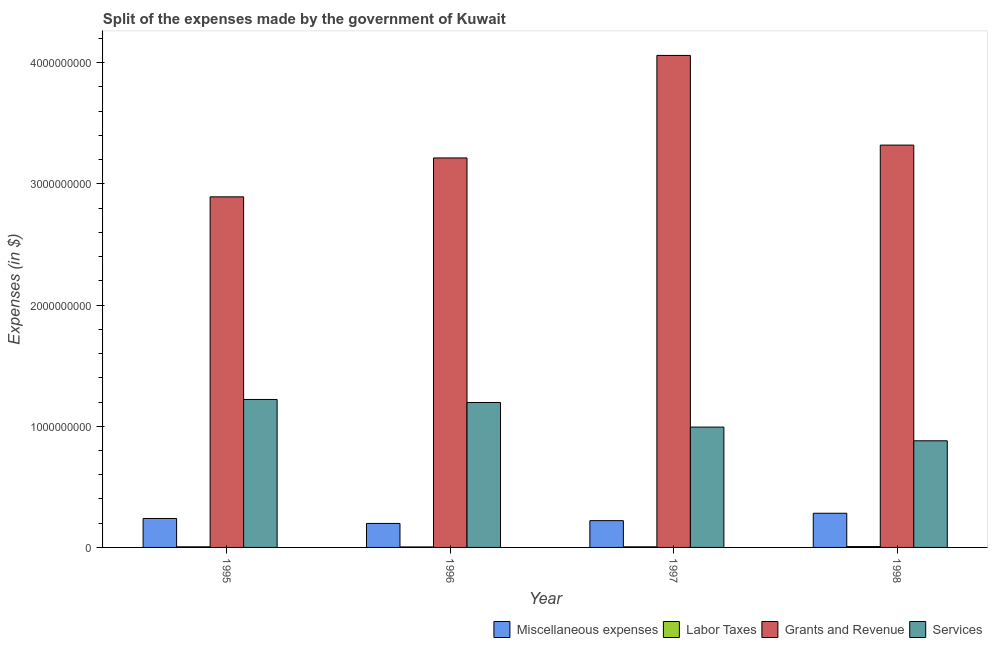How many groups of bars are there?
Offer a terse response. 4. Are the number of bars on each tick of the X-axis equal?
Keep it short and to the point. Yes. How many bars are there on the 1st tick from the left?
Your answer should be compact. 4. What is the amount spent on grants and revenue in 1995?
Make the answer very short. 2.89e+09. Across all years, what is the maximum amount spent on grants and revenue?
Offer a terse response. 4.06e+09. Across all years, what is the minimum amount spent on miscellaneous expenses?
Provide a succinct answer. 1.98e+08. In which year was the amount spent on labor taxes maximum?
Ensure brevity in your answer.  1998. In which year was the amount spent on miscellaneous expenses minimum?
Provide a succinct answer. 1996. What is the total amount spent on services in the graph?
Your answer should be very brief. 4.29e+09. What is the difference between the amount spent on grants and revenue in 1996 and that in 1998?
Provide a succinct answer. -1.06e+08. What is the difference between the amount spent on labor taxes in 1998 and the amount spent on services in 1996?
Offer a terse response. 3.00e+06. What is the average amount spent on services per year?
Keep it short and to the point. 1.07e+09. In the year 1995, what is the difference between the amount spent on services and amount spent on labor taxes?
Provide a short and direct response. 0. In how many years, is the amount spent on grants and revenue greater than 1800000000 $?
Offer a terse response. 4. What is the ratio of the amount spent on services in 1995 to that in 1998?
Provide a succinct answer. 1.39. What is the difference between the highest and the second highest amount spent on services?
Ensure brevity in your answer.  2.50e+07. What is the difference between the highest and the lowest amount spent on services?
Your answer should be very brief. 3.41e+08. In how many years, is the amount spent on miscellaneous expenses greater than the average amount spent on miscellaneous expenses taken over all years?
Ensure brevity in your answer.  2. What does the 3rd bar from the left in 1995 represents?
Provide a short and direct response. Grants and Revenue. What does the 1st bar from the right in 1998 represents?
Keep it short and to the point. Services. Is it the case that in every year, the sum of the amount spent on miscellaneous expenses and amount spent on labor taxes is greater than the amount spent on grants and revenue?
Give a very brief answer. No. Does the graph contain grids?
Keep it short and to the point. No. Where does the legend appear in the graph?
Offer a very short reply. Bottom right. How are the legend labels stacked?
Offer a terse response. Horizontal. What is the title of the graph?
Make the answer very short. Split of the expenses made by the government of Kuwait. What is the label or title of the X-axis?
Offer a very short reply. Year. What is the label or title of the Y-axis?
Your answer should be compact. Expenses (in $). What is the Expenses (in $) of Miscellaneous expenses in 1995?
Ensure brevity in your answer.  2.39e+08. What is the Expenses (in $) in Grants and Revenue in 1995?
Ensure brevity in your answer.  2.89e+09. What is the Expenses (in $) in Services in 1995?
Make the answer very short. 1.22e+09. What is the Expenses (in $) in Miscellaneous expenses in 1996?
Give a very brief answer. 1.98e+08. What is the Expenses (in $) of Grants and Revenue in 1996?
Your answer should be very brief. 3.21e+09. What is the Expenses (in $) of Services in 1996?
Ensure brevity in your answer.  1.20e+09. What is the Expenses (in $) of Miscellaneous expenses in 1997?
Provide a short and direct response. 2.21e+08. What is the Expenses (in $) in Grants and Revenue in 1997?
Keep it short and to the point. 4.06e+09. What is the Expenses (in $) in Services in 1997?
Your answer should be very brief. 9.93e+08. What is the Expenses (in $) in Miscellaneous expenses in 1998?
Ensure brevity in your answer.  2.82e+08. What is the Expenses (in $) in Labor Taxes in 1998?
Provide a succinct answer. 7.00e+06. What is the Expenses (in $) in Grants and Revenue in 1998?
Provide a succinct answer. 3.32e+09. What is the Expenses (in $) of Services in 1998?
Your response must be concise. 8.80e+08. Across all years, what is the maximum Expenses (in $) in Miscellaneous expenses?
Make the answer very short. 2.82e+08. Across all years, what is the maximum Expenses (in $) of Labor Taxes?
Ensure brevity in your answer.  7.00e+06. Across all years, what is the maximum Expenses (in $) in Grants and Revenue?
Your answer should be very brief. 4.06e+09. Across all years, what is the maximum Expenses (in $) in Services?
Your answer should be very brief. 1.22e+09. Across all years, what is the minimum Expenses (in $) in Miscellaneous expenses?
Keep it short and to the point. 1.98e+08. Across all years, what is the minimum Expenses (in $) of Labor Taxes?
Offer a very short reply. 4.00e+06. Across all years, what is the minimum Expenses (in $) of Grants and Revenue?
Provide a short and direct response. 2.89e+09. Across all years, what is the minimum Expenses (in $) of Services?
Provide a short and direct response. 8.80e+08. What is the total Expenses (in $) in Miscellaneous expenses in the graph?
Offer a terse response. 9.40e+08. What is the total Expenses (in $) of Labor Taxes in the graph?
Provide a short and direct response. 2.10e+07. What is the total Expenses (in $) of Grants and Revenue in the graph?
Provide a short and direct response. 1.35e+1. What is the total Expenses (in $) of Services in the graph?
Your answer should be very brief. 4.29e+09. What is the difference between the Expenses (in $) of Miscellaneous expenses in 1995 and that in 1996?
Ensure brevity in your answer.  4.10e+07. What is the difference between the Expenses (in $) of Labor Taxes in 1995 and that in 1996?
Make the answer very short. 1.00e+06. What is the difference between the Expenses (in $) of Grants and Revenue in 1995 and that in 1996?
Make the answer very short. -3.21e+08. What is the difference between the Expenses (in $) of Services in 1995 and that in 1996?
Keep it short and to the point. 2.50e+07. What is the difference between the Expenses (in $) of Miscellaneous expenses in 1995 and that in 1997?
Ensure brevity in your answer.  1.80e+07. What is the difference between the Expenses (in $) of Labor Taxes in 1995 and that in 1997?
Make the answer very short. 0. What is the difference between the Expenses (in $) in Grants and Revenue in 1995 and that in 1997?
Provide a short and direct response. -1.17e+09. What is the difference between the Expenses (in $) in Services in 1995 and that in 1997?
Provide a short and direct response. 2.28e+08. What is the difference between the Expenses (in $) in Miscellaneous expenses in 1995 and that in 1998?
Keep it short and to the point. -4.30e+07. What is the difference between the Expenses (in $) in Labor Taxes in 1995 and that in 1998?
Provide a short and direct response. -2.00e+06. What is the difference between the Expenses (in $) in Grants and Revenue in 1995 and that in 1998?
Make the answer very short. -4.27e+08. What is the difference between the Expenses (in $) of Services in 1995 and that in 1998?
Provide a short and direct response. 3.41e+08. What is the difference between the Expenses (in $) of Miscellaneous expenses in 1996 and that in 1997?
Provide a short and direct response. -2.30e+07. What is the difference between the Expenses (in $) in Labor Taxes in 1996 and that in 1997?
Your answer should be very brief. -1.00e+06. What is the difference between the Expenses (in $) in Grants and Revenue in 1996 and that in 1997?
Offer a terse response. -8.46e+08. What is the difference between the Expenses (in $) of Services in 1996 and that in 1997?
Offer a very short reply. 2.03e+08. What is the difference between the Expenses (in $) of Miscellaneous expenses in 1996 and that in 1998?
Your answer should be very brief. -8.40e+07. What is the difference between the Expenses (in $) of Grants and Revenue in 1996 and that in 1998?
Ensure brevity in your answer.  -1.06e+08. What is the difference between the Expenses (in $) of Services in 1996 and that in 1998?
Provide a succinct answer. 3.16e+08. What is the difference between the Expenses (in $) in Miscellaneous expenses in 1997 and that in 1998?
Provide a short and direct response. -6.10e+07. What is the difference between the Expenses (in $) of Grants and Revenue in 1997 and that in 1998?
Offer a terse response. 7.40e+08. What is the difference between the Expenses (in $) in Services in 1997 and that in 1998?
Keep it short and to the point. 1.13e+08. What is the difference between the Expenses (in $) in Miscellaneous expenses in 1995 and the Expenses (in $) in Labor Taxes in 1996?
Provide a succinct answer. 2.35e+08. What is the difference between the Expenses (in $) in Miscellaneous expenses in 1995 and the Expenses (in $) in Grants and Revenue in 1996?
Give a very brief answer. -2.98e+09. What is the difference between the Expenses (in $) of Miscellaneous expenses in 1995 and the Expenses (in $) of Services in 1996?
Your answer should be very brief. -9.57e+08. What is the difference between the Expenses (in $) of Labor Taxes in 1995 and the Expenses (in $) of Grants and Revenue in 1996?
Make the answer very short. -3.21e+09. What is the difference between the Expenses (in $) in Labor Taxes in 1995 and the Expenses (in $) in Services in 1996?
Give a very brief answer. -1.19e+09. What is the difference between the Expenses (in $) of Grants and Revenue in 1995 and the Expenses (in $) of Services in 1996?
Provide a succinct answer. 1.70e+09. What is the difference between the Expenses (in $) of Miscellaneous expenses in 1995 and the Expenses (in $) of Labor Taxes in 1997?
Keep it short and to the point. 2.34e+08. What is the difference between the Expenses (in $) of Miscellaneous expenses in 1995 and the Expenses (in $) of Grants and Revenue in 1997?
Make the answer very short. -3.82e+09. What is the difference between the Expenses (in $) in Miscellaneous expenses in 1995 and the Expenses (in $) in Services in 1997?
Ensure brevity in your answer.  -7.54e+08. What is the difference between the Expenses (in $) of Labor Taxes in 1995 and the Expenses (in $) of Grants and Revenue in 1997?
Keep it short and to the point. -4.06e+09. What is the difference between the Expenses (in $) in Labor Taxes in 1995 and the Expenses (in $) in Services in 1997?
Offer a terse response. -9.88e+08. What is the difference between the Expenses (in $) in Grants and Revenue in 1995 and the Expenses (in $) in Services in 1997?
Provide a short and direct response. 1.90e+09. What is the difference between the Expenses (in $) in Miscellaneous expenses in 1995 and the Expenses (in $) in Labor Taxes in 1998?
Make the answer very short. 2.32e+08. What is the difference between the Expenses (in $) in Miscellaneous expenses in 1995 and the Expenses (in $) in Grants and Revenue in 1998?
Offer a very short reply. -3.08e+09. What is the difference between the Expenses (in $) of Miscellaneous expenses in 1995 and the Expenses (in $) of Services in 1998?
Provide a succinct answer. -6.41e+08. What is the difference between the Expenses (in $) in Labor Taxes in 1995 and the Expenses (in $) in Grants and Revenue in 1998?
Make the answer very short. -3.32e+09. What is the difference between the Expenses (in $) in Labor Taxes in 1995 and the Expenses (in $) in Services in 1998?
Your answer should be very brief. -8.75e+08. What is the difference between the Expenses (in $) in Grants and Revenue in 1995 and the Expenses (in $) in Services in 1998?
Your response must be concise. 2.01e+09. What is the difference between the Expenses (in $) of Miscellaneous expenses in 1996 and the Expenses (in $) of Labor Taxes in 1997?
Make the answer very short. 1.93e+08. What is the difference between the Expenses (in $) in Miscellaneous expenses in 1996 and the Expenses (in $) in Grants and Revenue in 1997?
Your answer should be compact. -3.86e+09. What is the difference between the Expenses (in $) in Miscellaneous expenses in 1996 and the Expenses (in $) in Services in 1997?
Keep it short and to the point. -7.95e+08. What is the difference between the Expenses (in $) in Labor Taxes in 1996 and the Expenses (in $) in Grants and Revenue in 1997?
Your answer should be compact. -4.06e+09. What is the difference between the Expenses (in $) in Labor Taxes in 1996 and the Expenses (in $) in Services in 1997?
Offer a terse response. -9.89e+08. What is the difference between the Expenses (in $) of Grants and Revenue in 1996 and the Expenses (in $) of Services in 1997?
Make the answer very short. 2.22e+09. What is the difference between the Expenses (in $) in Miscellaneous expenses in 1996 and the Expenses (in $) in Labor Taxes in 1998?
Provide a short and direct response. 1.91e+08. What is the difference between the Expenses (in $) of Miscellaneous expenses in 1996 and the Expenses (in $) of Grants and Revenue in 1998?
Your answer should be compact. -3.12e+09. What is the difference between the Expenses (in $) of Miscellaneous expenses in 1996 and the Expenses (in $) of Services in 1998?
Give a very brief answer. -6.82e+08. What is the difference between the Expenses (in $) in Labor Taxes in 1996 and the Expenses (in $) in Grants and Revenue in 1998?
Keep it short and to the point. -3.32e+09. What is the difference between the Expenses (in $) in Labor Taxes in 1996 and the Expenses (in $) in Services in 1998?
Offer a very short reply. -8.76e+08. What is the difference between the Expenses (in $) of Grants and Revenue in 1996 and the Expenses (in $) of Services in 1998?
Your answer should be very brief. 2.33e+09. What is the difference between the Expenses (in $) of Miscellaneous expenses in 1997 and the Expenses (in $) of Labor Taxes in 1998?
Offer a terse response. 2.14e+08. What is the difference between the Expenses (in $) of Miscellaneous expenses in 1997 and the Expenses (in $) of Grants and Revenue in 1998?
Provide a short and direct response. -3.10e+09. What is the difference between the Expenses (in $) of Miscellaneous expenses in 1997 and the Expenses (in $) of Services in 1998?
Your answer should be very brief. -6.59e+08. What is the difference between the Expenses (in $) in Labor Taxes in 1997 and the Expenses (in $) in Grants and Revenue in 1998?
Make the answer very short. -3.32e+09. What is the difference between the Expenses (in $) in Labor Taxes in 1997 and the Expenses (in $) in Services in 1998?
Offer a very short reply. -8.75e+08. What is the difference between the Expenses (in $) of Grants and Revenue in 1997 and the Expenses (in $) of Services in 1998?
Keep it short and to the point. 3.18e+09. What is the average Expenses (in $) of Miscellaneous expenses per year?
Your response must be concise. 2.35e+08. What is the average Expenses (in $) in Labor Taxes per year?
Offer a very short reply. 5.25e+06. What is the average Expenses (in $) in Grants and Revenue per year?
Provide a short and direct response. 3.37e+09. What is the average Expenses (in $) of Services per year?
Provide a short and direct response. 1.07e+09. In the year 1995, what is the difference between the Expenses (in $) of Miscellaneous expenses and Expenses (in $) of Labor Taxes?
Offer a terse response. 2.34e+08. In the year 1995, what is the difference between the Expenses (in $) in Miscellaneous expenses and Expenses (in $) in Grants and Revenue?
Keep it short and to the point. -2.65e+09. In the year 1995, what is the difference between the Expenses (in $) in Miscellaneous expenses and Expenses (in $) in Services?
Give a very brief answer. -9.82e+08. In the year 1995, what is the difference between the Expenses (in $) of Labor Taxes and Expenses (in $) of Grants and Revenue?
Provide a succinct answer. -2.89e+09. In the year 1995, what is the difference between the Expenses (in $) of Labor Taxes and Expenses (in $) of Services?
Provide a succinct answer. -1.22e+09. In the year 1995, what is the difference between the Expenses (in $) in Grants and Revenue and Expenses (in $) in Services?
Your response must be concise. 1.67e+09. In the year 1996, what is the difference between the Expenses (in $) of Miscellaneous expenses and Expenses (in $) of Labor Taxes?
Offer a very short reply. 1.94e+08. In the year 1996, what is the difference between the Expenses (in $) in Miscellaneous expenses and Expenses (in $) in Grants and Revenue?
Provide a short and direct response. -3.02e+09. In the year 1996, what is the difference between the Expenses (in $) of Miscellaneous expenses and Expenses (in $) of Services?
Your answer should be compact. -9.98e+08. In the year 1996, what is the difference between the Expenses (in $) in Labor Taxes and Expenses (in $) in Grants and Revenue?
Keep it short and to the point. -3.21e+09. In the year 1996, what is the difference between the Expenses (in $) in Labor Taxes and Expenses (in $) in Services?
Provide a succinct answer. -1.19e+09. In the year 1996, what is the difference between the Expenses (in $) of Grants and Revenue and Expenses (in $) of Services?
Give a very brief answer. 2.02e+09. In the year 1997, what is the difference between the Expenses (in $) in Miscellaneous expenses and Expenses (in $) in Labor Taxes?
Your response must be concise. 2.16e+08. In the year 1997, what is the difference between the Expenses (in $) of Miscellaneous expenses and Expenses (in $) of Grants and Revenue?
Ensure brevity in your answer.  -3.84e+09. In the year 1997, what is the difference between the Expenses (in $) of Miscellaneous expenses and Expenses (in $) of Services?
Keep it short and to the point. -7.72e+08. In the year 1997, what is the difference between the Expenses (in $) in Labor Taxes and Expenses (in $) in Grants and Revenue?
Provide a succinct answer. -4.06e+09. In the year 1997, what is the difference between the Expenses (in $) in Labor Taxes and Expenses (in $) in Services?
Your response must be concise. -9.88e+08. In the year 1997, what is the difference between the Expenses (in $) in Grants and Revenue and Expenses (in $) in Services?
Keep it short and to the point. 3.07e+09. In the year 1998, what is the difference between the Expenses (in $) in Miscellaneous expenses and Expenses (in $) in Labor Taxes?
Your answer should be compact. 2.75e+08. In the year 1998, what is the difference between the Expenses (in $) of Miscellaneous expenses and Expenses (in $) of Grants and Revenue?
Offer a very short reply. -3.04e+09. In the year 1998, what is the difference between the Expenses (in $) of Miscellaneous expenses and Expenses (in $) of Services?
Give a very brief answer. -5.98e+08. In the year 1998, what is the difference between the Expenses (in $) in Labor Taxes and Expenses (in $) in Grants and Revenue?
Make the answer very short. -3.31e+09. In the year 1998, what is the difference between the Expenses (in $) of Labor Taxes and Expenses (in $) of Services?
Ensure brevity in your answer.  -8.73e+08. In the year 1998, what is the difference between the Expenses (in $) of Grants and Revenue and Expenses (in $) of Services?
Offer a terse response. 2.44e+09. What is the ratio of the Expenses (in $) of Miscellaneous expenses in 1995 to that in 1996?
Provide a short and direct response. 1.21. What is the ratio of the Expenses (in $) in Grants and Revenue in 1995 to that in 1996?
Give a very brief answer. 0.9. What is the ratio of the Expenses (in $) of Services in 1995 to that in 1996?
Your response must be concise. 1.02. What is the ratio of the Expenses (in $) of Miscellaneous expenses in 1995 to that in 1997?
Provide a succinct answer. 1.08. What is the ratio of the Expenses (in $) of Grants and Revenue in 1995 to that in 1997?
Provide a short and direct response. 0.71. What is the ratio of the Expenses (in $) of Services in 1995 to that in 1997?
Your answer should be compact. 1.23. What is the ratio of the Expenses (in $) of Miscellaneous expenses in 1995 to that in 1998?
Keep it short and to the point. 0.85. What is the ratio of the Expenses (in $) of Labor Taxes in 1995 to that in 1998?
Provide a short and direct response. 0.71. What is the ratio of the Expenses (in $) in Grants and Revenue in 1995 to that in 1998?
Make the answer very short. 0.87. What is the ratio of the Expenses (in $) of Services in 1995 to that in 1998?
Your answer should be very brief. 1.39. What is the ratio of the Expenses (in $) of Miscellaneous expenses in 1996 to that in 1997?
Your response must be concise. 0.9. What is the ratio of the Expenses (in $) of Labor Taxes in 1996 to that in 1997?
Provide a succinct answer. 0.8. What is the ratio of the Expenses (in $) in Grants and Revenue in 1996 to that in 1997?
Make the answer very short. 0.79. What is the ratio of the Expenses (in $) of Services in 1996 to that in 1997?
Your answer should be compact. 1.2. What is the ratio of the Expenses (in $) of Miscellaneous expenses in 1996 to that in 1998?
Your response must be concise. 0.7. What is the ratio of the Expenses (in $) in Labor Taxes in 1996 to that in 1998?
Make the answer very short. 0.57. What is the ratio of the Expenses (in $) in Grants and Revenue in 1996 to that in 1998?
Provide a short and direct response. 0.97. What is the ratio of the Expenses (in $) of Services in 1996 to that in 1998?
Ensure brevity in your answer.  1.36. What is the ratio of the Expenses (in $) in Miscellaneous expenses in 1997 to that in 1998?
Your response must be concise. 0.78. What is the ratio of the Expenses (in $) in Grants and Revenue in 1997 to that in 1998?
Your answer should be compact. 1.22. What is the ratio of the Expenses (in $) of Services in 1997 to that in 1998?
Provide a short and direct response. 1.13. What is the difference between the highest and the second highest Expenses (in $) of Miscellaneous expenses?
Your answer should be very brief. 4.30e+07. What is the difference between the highest and the second highest Expenses (in $) of Grants and Revenue?
Your response must be concise. 7.40e+08. What is the difference between the highest and the second highest Expenses (in $) in Services?
Provide a succinct answer. 2.50e+07. What is the difference between the highest and the lowest Expenses (in $) of Miscellaneous expenses?
Ensure brevity in your answer.  8.40e+07. What is the difference between the highest and the lowest Expenses (in $) of Labor Taxes?
Ensure brevity in your answer.  3.00e+06. What is the difference between the highest and the lowest Expenses (in $) in Grants and Revenue?
Provide a succinct answer. 1.17e+09. What is the difference between the highest and the lowest Expenses (in $) in Services?
Provide a short and direct response. 3.41e+08. 